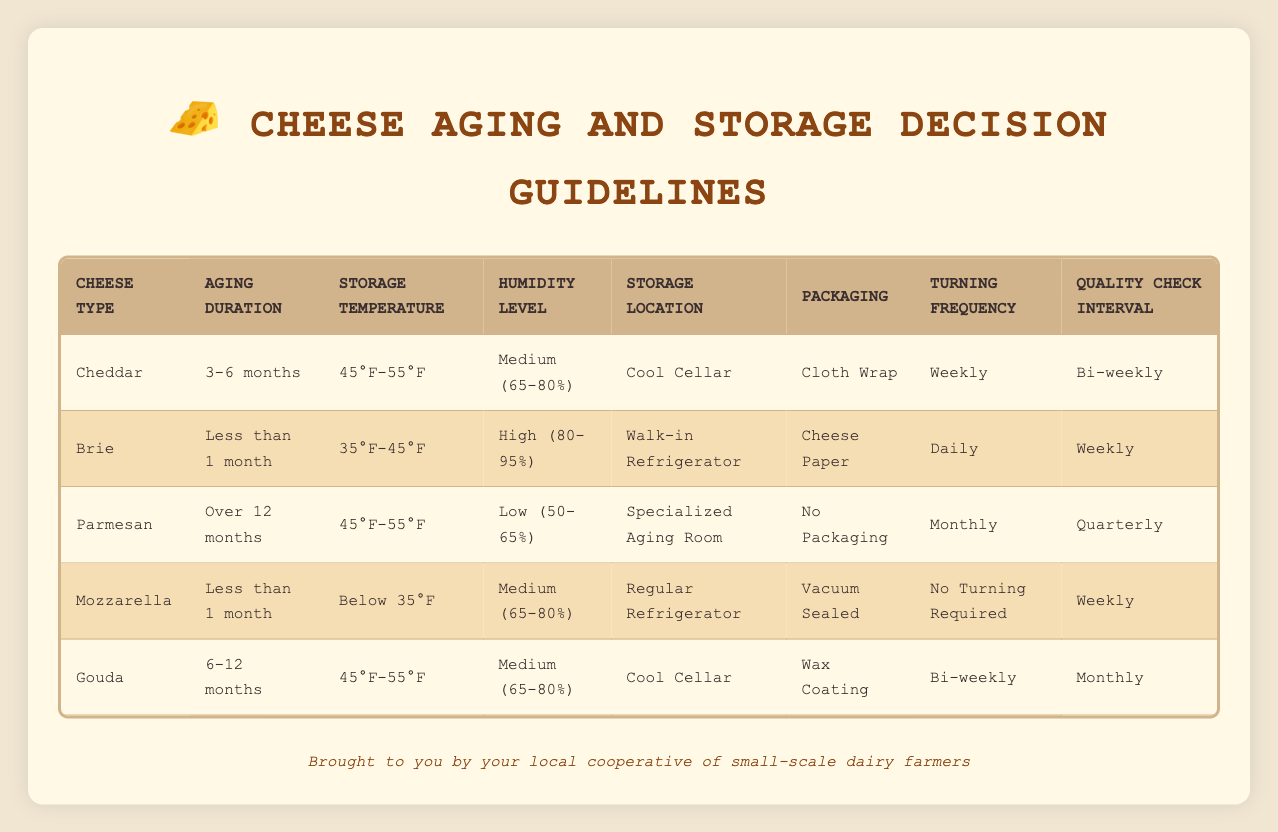What storage location is recommended for Gouda cheese that is aged 6-12 months? It can be found directly in the row for Gouda cheese, where the storage location specified is Cool Cellar.
Answer: Cool Cellar What packaging is suggested for Brie cheese aged for less than 1 month? Looking at the Brie row, it shows that cheese paper is the advised packaging for Brie aged less than 1 month.
Answer: Cheese Paper Is it necessary to turn Parmesan cheese that has been aged for over 12 months? The table states that Parmesan cheese should be turned monthly, implying it does require turning.
Answer: Yes What is the quality check interval for cheddar that's aged between 3-6 months? From the cheddar entry, we can see that the quality check should occur bi-weekly for cheddar aged 3-6 months.
Answer: Bi-weekly How many types of cheese require a storage temperature between 45°F and 55°F? By examining the table, I can see that both Cheddar and Gouda require this temperature, thus making a total of 2 types.
Answer: 2 What is the most frequent turning frequency for any cheese type mentioned in the table? By reviewing all cheese types, the highest frequency is daily, which is indicated for Brie cheese.
Answer: Daily Does Mozzarella cheese aged for less than a month require turning? The table specifies that Mozzarella does not require turning, as it states “No Turning Required.”
Answer: No What are the recommended storage conditions for cheese aged over 12 months? The table indicates that Parmesan cheese, the only cheese aged over 12 months, should be stored in a Specialized Aging Room, at 45°F-55°F, with low humidity (50-65%).
Answer: Specialized Aging Room, 45°F-55°F, Low (50-65%) What packaging should Gouda cheese aged 6-12 months use? The Gouda row reveals that Gouda cheese should be packaged with wax coating when aged for 6-12 months.
Answer: Wax Coating 